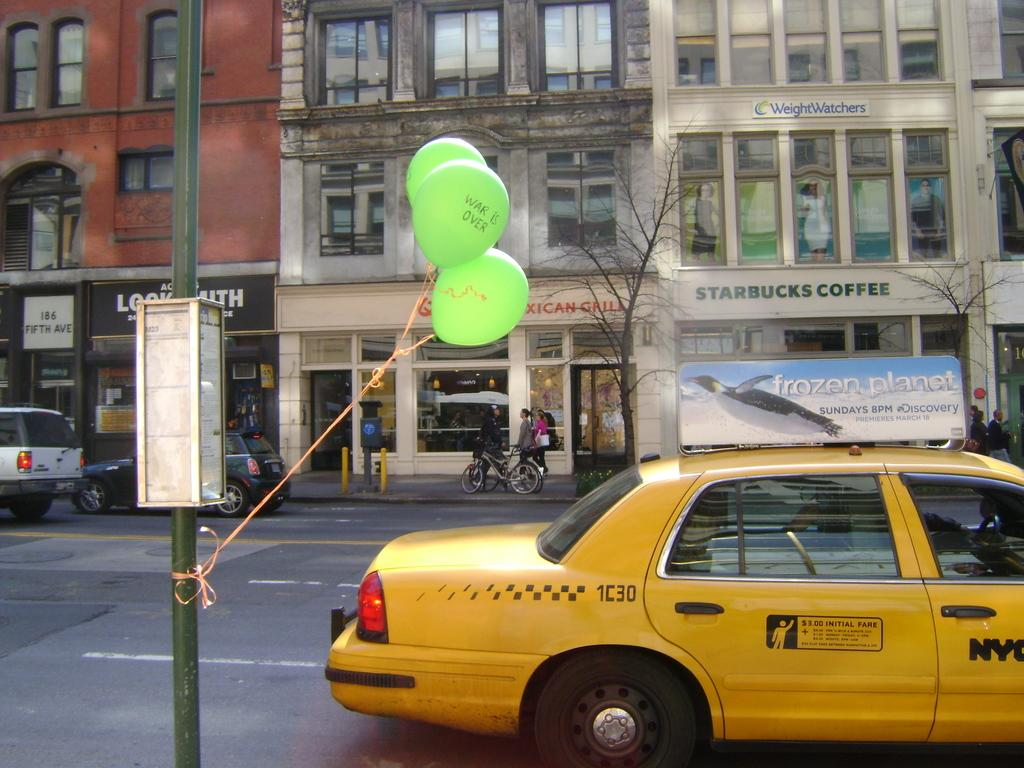What can be seen on the road in the image? There are vehicles on the road in the image. What is visible in the background of the image? There are buildings, trees, and name boards in the background of the image. What is tied to a pole in the image? Balloons are tied to a pole in the image. Where can the field be found in the image? There is no field present in the image. How does the pole sleep in the image? The pole does not sleep in the image, as it is an inanimate object. 